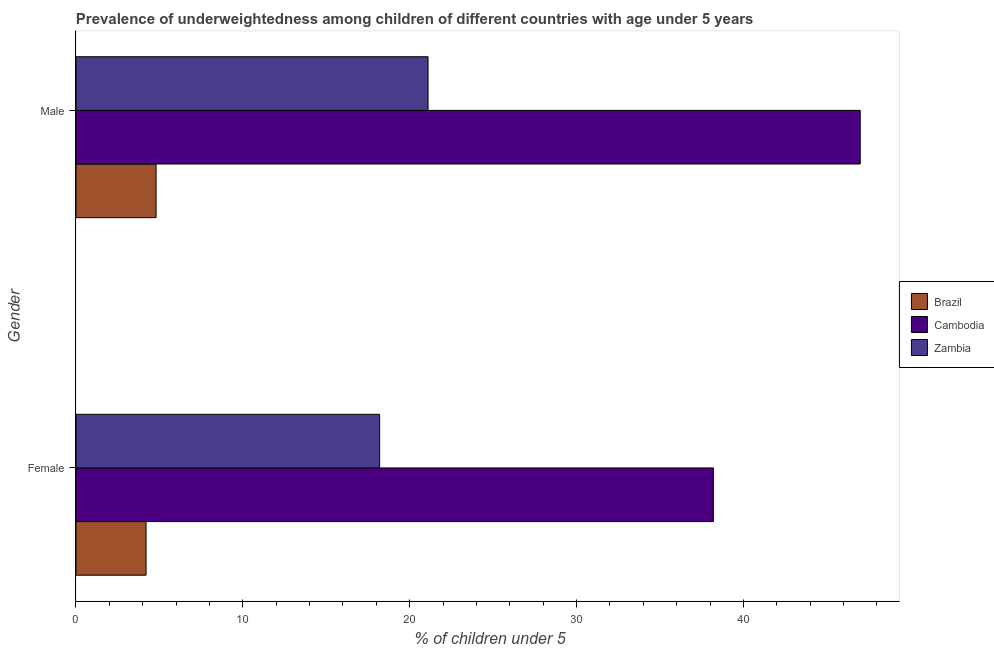How many groups of bars are there?
Provide a short and direct response. 2. How many bars are there on the 1st tick from the top?
Offer a terse response. 3. How many bars are there on the 2nd tick from the bottom?
Give a very brief answer. 3. What is the percentage of underweighted male children in Zambia?
Make the answer very short. 21.1. Across all countries, what is the maximum percentage of underweighted male children?
Make the answer very short. 47. Across all countries, what is the minimum percentage of underweighted male children?
Your answer should be compact. 4.8. In which country was the percentage of underweighted female children maximum?
Offer a very short reply. Cambodia. What is the total percentage of underweighted female children in the graph?
Make the answer very short. 60.6. What is the difference between the percentage of underweighted female children in Zambia and that in Cambodia?
Make the answer very short. -20. What is the difference between the percentage of underweighted female children in Cambodia and the percentage of underweighted male children in Brazil?
Your response must be concise. 33.4. What is the average percentage of underweighted male children per country?
Provide a short and direct response. 24.3. What is the difference between the percentage of underweighted male children and percentage of underweighted female children in Cambodia?
Provide a succinct answer. 8.8. In how many countries, is the percentage of underweighted female children greater than 18 %?
Offer a terse response. 2. What is the ratio of the percentage of underweighted male children in Cambodia to that in Brazil?
Offer a terse response. 9.79. Is the percentage of underweighted male children in Zambia less than that in Cambodia?
Your answer should be very brief. Yes. What does the 2nd bar from the top in Male represents?
Keep it short and to the point. Cambodia. What does the 3rd bar from the bottom in Male represents?
Offer a terse response. Zambia. Are all the bars in the graph horizontal?
Give a very brief answer. Yes. What is the difference between two consecutive major ticks on the X-axis?
Your response must be concise. 10. Does the graph contain any zero values?
Your answer should be compact. No. Where does the legend appear in the graph?
Provide a short and direct response. Center right. How many legend labels are there?
Your response must be concise. 3. How are the legend labels stacked?
Offer a terse response. Vertical. What is the title of the graph?
Provide a short and direct response. Prevalence of underweightedness among children of different countries with age under 5 years. Does "Libya" appear as one of the legend labels in the graph?
Keep it short and to the point. No. What is the label or title of the X-axis?
Give a very brief answer.  % of children under 5. What is the  % of children under 5 in Brazil in Female?
Your response must be concise. 4.2. What is the  % of children under 5 in Cambodia in Female?
Provide a succinct answer. 38.2. What is the  % of children under 5 in Zambia in Female?
Make the answer very short. 18.2. What is the  % of children under 5 in Brazil in Male?
Your answer should be very brief. 4.8. What is the  % of children under 5 in Cambodia in Male?
Your answer should be very brief. 47. What is the  % of children under 5 of Zambia in Male?
Make the answer very short. 21.1. Across all Gender, what is the maximum  % of children under 5 of Brazil?
Provide a short and direct response. 4.8. Across all Gender, what is the maximum  % of children under 5 in Cambodia?
Offer a terse response. 47. Across all Gender, what is the maximum  % of children under 5 in Zambia?
Ensure brevity in your answer.  21.1. Across all Gender, what is the minimum  % of children under 5 of Brazil?
Give a very brief answer. 4.2. Across all Gender, what is the minimum  % of children under 5 of Cambodia?
Make the answer very short. 38.2. Across all Gender, what is the minimum  % of children under 5 of Zambia?
Offer a very short reply. 18.2. What is the total  % of children under 5 of Brazil in the graph?
Your answer should be very brief. 9. What is the total  % of children under 5 of Cambodia in the graph?
Make the answer very short. 85.2. What is the total  % of children under 5 in Zambia in the graph?
Provide a short and direct response. 39.3. What is the difference between the  % of children under 5 in Brazil in Female and the  % of children under 5 in Cambodia in Male?
Your answer should be compact. -42.8. What is the difference between the  % of children under 5 in Brazil in Female and the  % of children under 5 in Zambia in Male?
Offer a terse response. -16.9. What is the average  % of children under 5 in Cambodia per Gender?
Offer a terse response. 42.6. What is the average  % of children under 5 in Zambia per Gender?
Provide a succinct answer. 19.65. What is the difference between the  % of children under 5 of Brazil and  % of children under 5 of Cambodia in Female?
Your answer should be compact. -34. What is the difference between the  % of children under 5 in Brazil and  % of children under 5 in Zambia in Female?
Keep it short and to the point. -14. What is the difference between the  % of children under 5 of Cambodia and  % of children under 5 of Zambia in Female?
Your response must be concise. 20. What is the difference between the  % of children under 5 of Brazil and  % of children under 5 of Cambodia in Male?
Provide a short and direct response. -42.2. What is the difference between the  % of children under 5 of Brazil and  % of children under 5 of Zambia in Male?
Provide a succinct answer. -16.3. What is the difference between the  % of children under 5 in Cambodia and  % of children under 5 in Zambia in Male?
Offer a terse response. 25.9. What is the ratio of the  % of children under 5 in Cambodia in Female to that in Male?
Provide a succinct answer. 0.81. What is the ratio of the  % of children under 5 of Zambia in Female to that in Male?
Your response must be concise. 0.86. What is the difference between the highest and the second highest  % of children under 5 of Brazil?
Give a very brief answer. 0.6. What is the difference between the highest and the second highest  % of children under 5 of Cambodia?
Your answer should be very brief. 8.8. What is the difference between the highest and the second highest  % of children under 5 in Zambia?
Make the answer very short. 2.9. What is the difference between the highest and the lowest  % of children under 5 of Brazil?
Provide a succinct answer. 0.6. What is the difference between the highest and the lowest  % of children under 5 in Cambodia?
Ensure brevity in your answer.  8.8. 